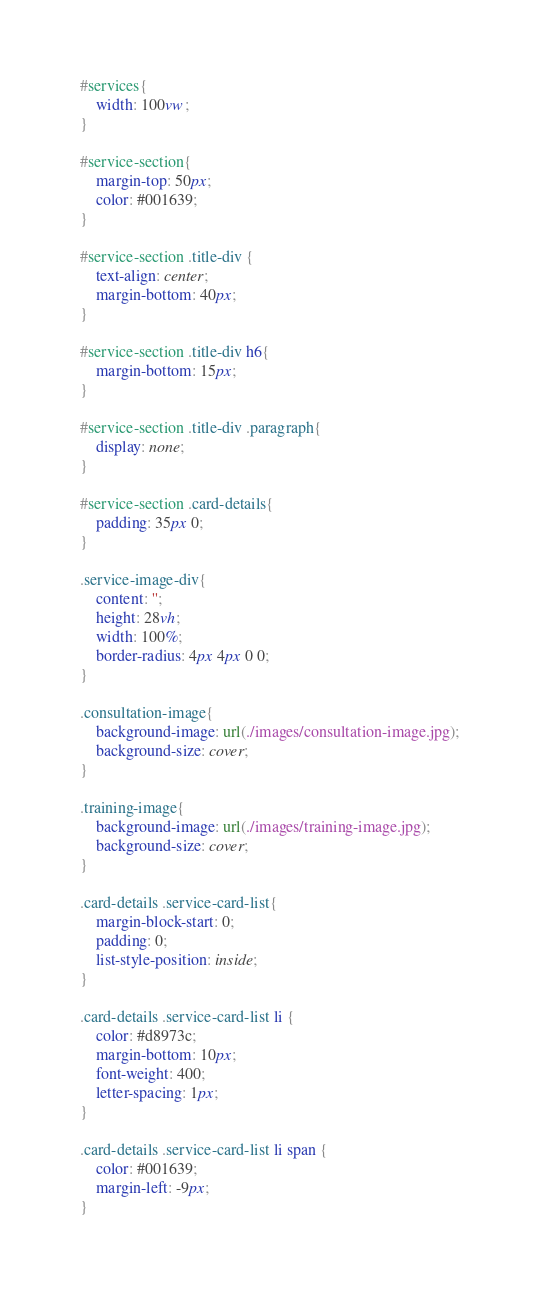Convert code to text. <code><loc_0><loc_0><loc_500><loc_500><_CSS_>#services{
    width: 100vw;
}

#service-section{
    margin-top: 50px;
    color: #001639;
}

#service-section .title-div {
    text-align: center;
    margin-bottom: 40px;
}

#service-section .title-div h6{
    margin-bottom: 15px;
}

#service-section .title-div .paragraph{
    display: none;
}

#service-section .card-details{
    padding: 35px 0;
}

.service-image-div{
    content: '';
    height: 28vh;
    width: 100%;
    border-radius: 4px 4px 0 0;
}

.consultation-image{
    background-image: url(./images/consultation-image.jpg);
    background-size: cover;
}

.training-image{
    background-image: url(./images/training-image.jpg);
    background-size: cover;
}

.card-details .service-card-list{
    margin-block-start: 0;
    padding: 0;
    list-style-position: inside;
}

.card-details .service-card-list li {
    color: #d8973c;
    margin-bottom: 10px;
    font-weight: 400;
    letter-spacing: 1px;
}

.card-details .service-card-list li span {
    color: #001639;
    margin-left: -9px;
}


</code> 